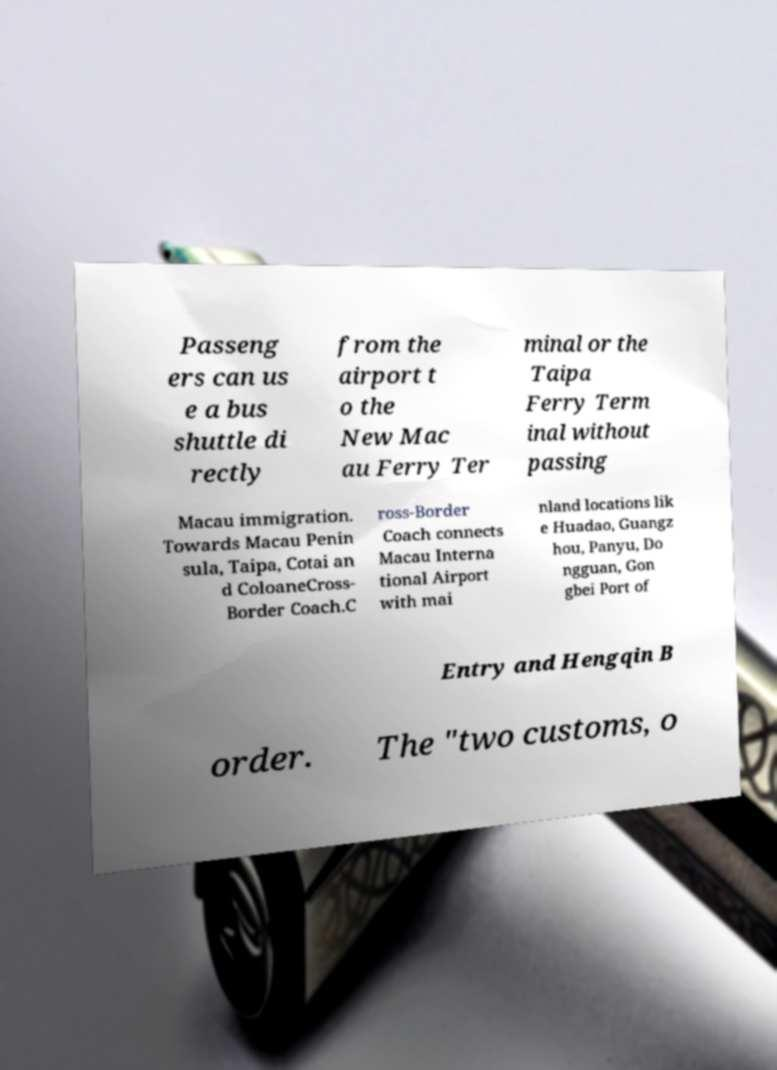Please identify and transcribe the text found in this image. Passeng ers can us e a bus shuttle di rectly from the airport t o the New Mac au Ferry Ter minal or the Taipa Ferry Term inal without passing Macau immigration. Towards Macau Penin sula, Taipa, Cotai an d ColoaneCross- Border Coach.C ross-Border Coach connects Macau Interna tional Airport with mai nland locations lik e Huadao, Guangz hou, Panyu, Do ngguan, Gon gbei Port of Entry and Hengqin B order. The "two customs, o 